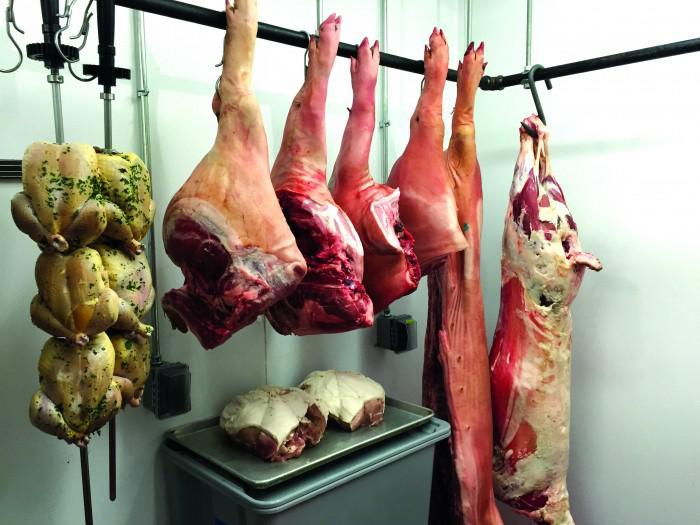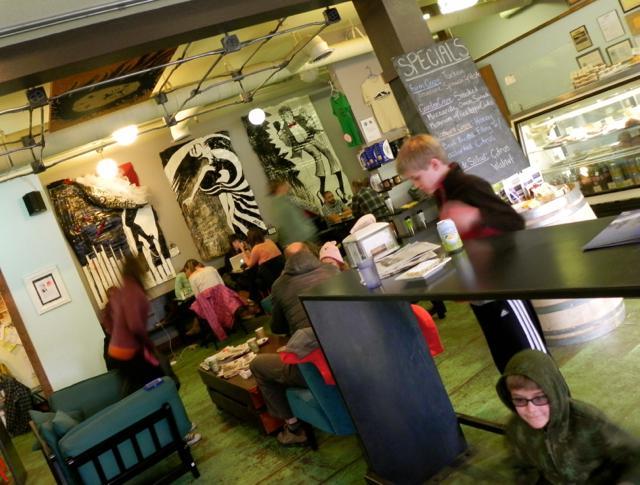The first image is the image on the left, the second image is the image on the right. Given the left and right images, does the statement "The left image includes a man wearing black on top standing in front of a counter, and a white tray containing food." hold true? Answer yes or no. No. The first image is the image on the left, the second image is the image on the right. Assess this claim about the two images: "There are customers sitting.". Correct or not? Answer yes or no. Yes. 